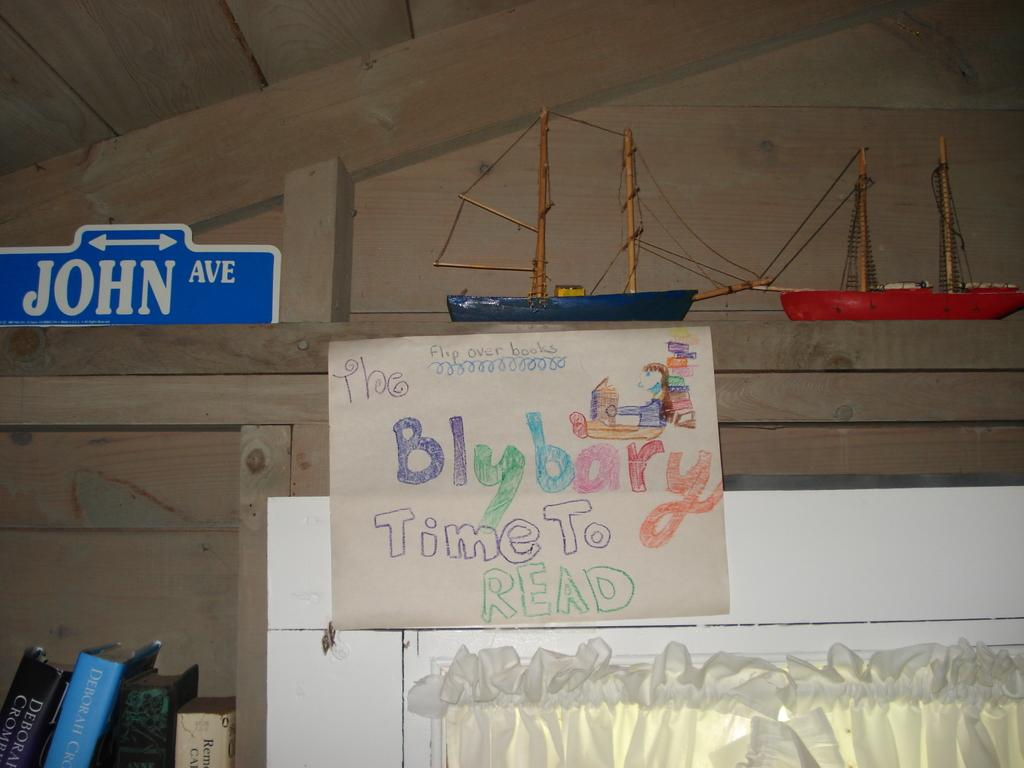Provide a one-sentence caption for the provided image. A sign that says The Blybary time to read with a blue and red sail boat above it. 